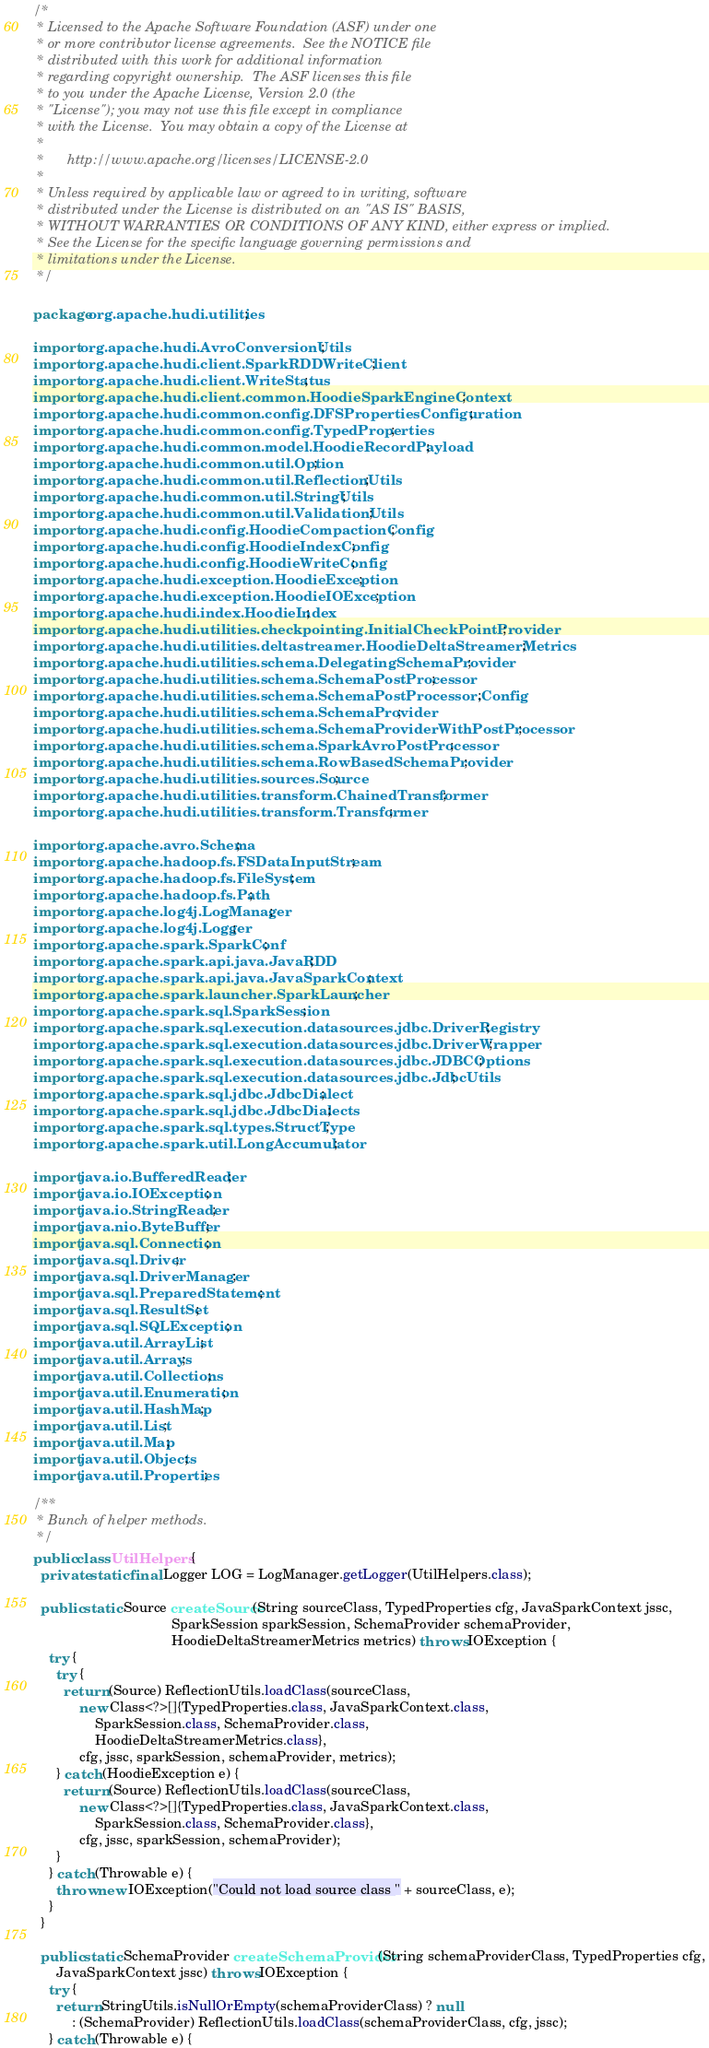Convert code to text. <code><loc_0><loc_0><loc_500><loc_500><_Java_>/*
 * Licensed to the Apache Software Foundation (ASF) under one
 * or more contributor license agreements.  See the NOTICE file
 * distributed with this work for additional information
 * regarding copyright ownership.  The ASF licenses this file
 * to you under the Apache License, Version 2.0 (the
 * "License"); you may not use this file except in compliance
 * with the License.  You may obtain a copy of the License at
 *
 *      http://www.apache.org/licenses/LICENSE-2.0
 *
 * Unless required by applicable law or agreed to in writing, software
 * distributed under the License is distributed on an "AS IS" BASIS,
 * WITHOUT WARRANTIES OR CONDITIONS OF ANY KIND, either express or implied.
 * See the License for the specific language governing permissions and
 * limitations under the License.
 */

package org.apache.hudi.utilities;

import org.apache.hudi.AvroConversionUtils;
import org.apache.hudi.client.SparkRDDWriteClient;
import org.apache.hudi.client.WriteStatus;
import org.apache.hudi.client.common.HoodieSparkEngineContext;
import org.apache.hudi.common.config.DFSPropertiesConfiguration;
import org.apache.hudi.common.config.TypedProperties;
import org.apache.hudi.common.model.HoodieRecordPayload;
import org.apache.hudi.common.util.Option;
import org.apache.hudi.common.util.ReflectionUtils;
import org.apache.hudi.common.util.StringUtils;
import org.apache.hudi.common.util.ValidationUtils;
import org.apache.hudi.config.HoodieCompactionConfig;
import org.apache.hudi.config.HoodieIndexConfig;
import org.apache.hudi.config.HoodieWriteConfig;
import org.apache.hudi.exception.HoodieException;
import org.apache.hudi.exception.HoodieIOException;
import org.apache.hudi.index.HoodieIndex;
import org.apache.hudi.utilities.checkpointing.InitialCheckPointProvider;
import org.apache.hudi.utilities.deltastreamer.HoodieDeltaStreamerMetrics;
import org.apache.hudi.utilities.schema.DelegatingSchemaProvider;
import org.apache.hudi.utilities.schema.SchemaPostProcessor;
import org.apache.hudi.utilities.schema.SchemaPostProcessor.Config;
import org.apache.hudi.utilities.schema.SchemaProvider;
import org.apache.hudi.utilities.schema.SchemaProviderWithPostProcessor;
import org.apache.hudi.utilities.schema.SparkAvroPostProcessor;
import org.apache.hudi.utilities.schema.RowBasedSchemaProvider;
import org.apache.hudi.utilities.sources.Source;
import org.apache.hudi.utilities.transform.ChainedTransformer;
import org.apache.hudi.utilities.transform.Transformer;

import org.apache.avro.Schema;
import org.apache.hadoop.fs.FSDataInputStream;
import org.apache.hadoop.fs.FileSystem;
import org.apache.hadoop.fs.Path;
import org.apache.log4j.LogManager;
import org.apache.log4j.Logger;
import org.apache.spark.SparkConf;
import org.apache.spark.api.java.JavaRDD;
import org.apache.spark.api.java.JavaSparkContext;
import org.apache.spark.launcher.SparkLauncher;
import org.apache.spark.sql.SparkSession;
import org.apache.spark.sql.execution.datasources.jdbc.DriverRegistry;
import org.apache.spark.sql.execution.datasources.jdbc.DriverWrapper;
import org.apache.spark.sql.execution.datasources.jdbc.JDBCOptions;
import org.apache.spark.sql.execution.datasources.jdbc.JdbcUtils;
import org.apache.spark.sql.jdbc.JdbcDialect;
import org.apache.spark.sql.jdbc.JdbcDialects;
import org.apache.spark.sql.types.StructType;
import org.apache.spark.util.LongAccumulator;

import java.io.BufferedReader;
import java.io.IOException;
import java.io.StringReader;
import java.nio.ByteBuffer;
import java.sql.Connection;
import java.sql.Driver;
import java.sql.DriverManager;
import java.sql.PreparedStatement;
import java.sql.ResultSet;
import java.sql.SQLException;
import java.util.ArrayList;
import java.util.Arrays;
import java.util.Collections;
import java.util.Enumeration;
import java.util.HashMap;
import java.util.List;
import java.util.Map;
import java.util.Objects;
import java.util.Properties;

/**
 * Bunch of helper methods.
 */
public class UtilHelpers {
  private static final Logger LOG = LogManager.getLogger(UtilHelpers.class);

  public static Source createSource(String sourceClass, TypedProperties cfg, JavaSparkContext jssc,
                                    SparkSession sparkSession, SchemaProvider schemaProvider,
                                    HoodieDeltaStreamerMetrics metrics) throws IOException {
    try {
      try {
        return (Source) ReflectionUtils.loadClass(sourceClass,
            new Class<?>[]{TypedProperties.class, JavaSparkContext.class,
                SparkSession.class, SchemaProvider.class,
                HoodieDeltaStreamerMetrics.class},
            cfg, jssc, sparkSession, schemaProvider, metrics);
      } catch (HoodieException e) {
        return (Source) ReflectionUtils.loadClass(sourceClass,
            new Class<?>[]{TypedProperties.class, JavaSparkContext.class,
                SparkSession.class, SchemaProvider.class},
            cfg, jssc, sparkSession, schemaProvider);
      }
    } catch (Throwable e) {
      throw new IOException("Could not load source class " + sourceClass, e);
    }
  }

  public static SchemaProvider createSchemaProvider(String schemaProviderClass, TypedProperties cfg,
      JavaSparkContext jssc) throws IOException {
    try {
      return StringUtils.isNullOrEmpty(schemaProviderClass) ? null
          : (SchemaProvider) ReflectionUtils.loadClass(schemaProviderClass, cfg, jssc);
    } catch (Throwable e) {</code> 